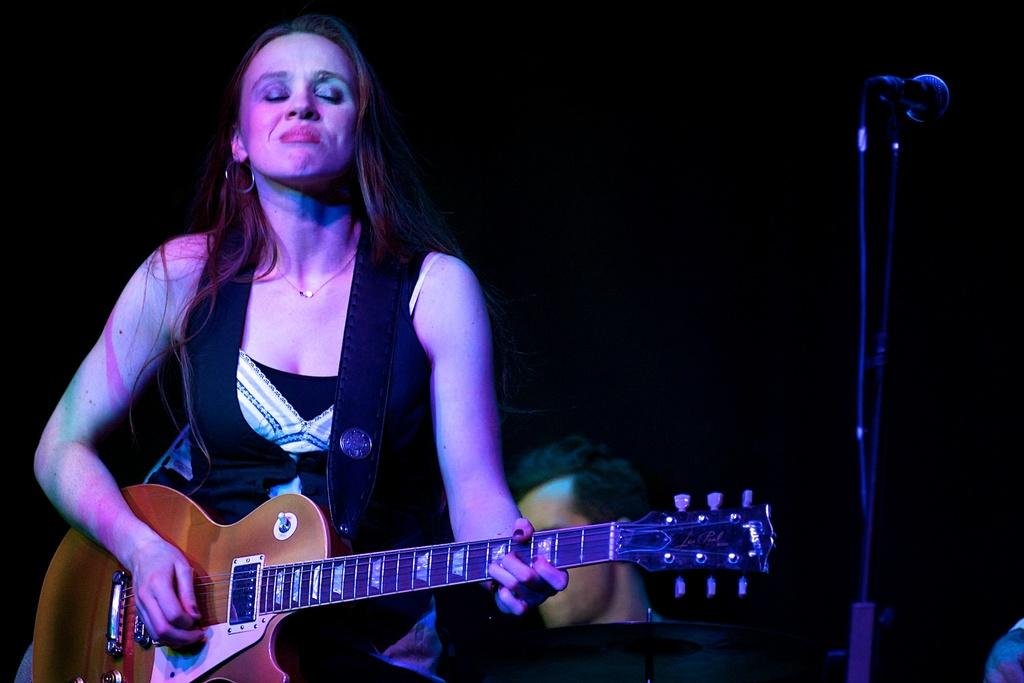What is the main subject of the image? There is a person standing in the image. What is the person doing in the image? The person is playing a guitar. Can you describe the background of the image? There is another person visible in the background of the image. What is the amount of debt the person playing the guitar has in the image? There is no information about the person's debt in the image, as the focus is on the person playing the guitar and the presence of another person in the background. 